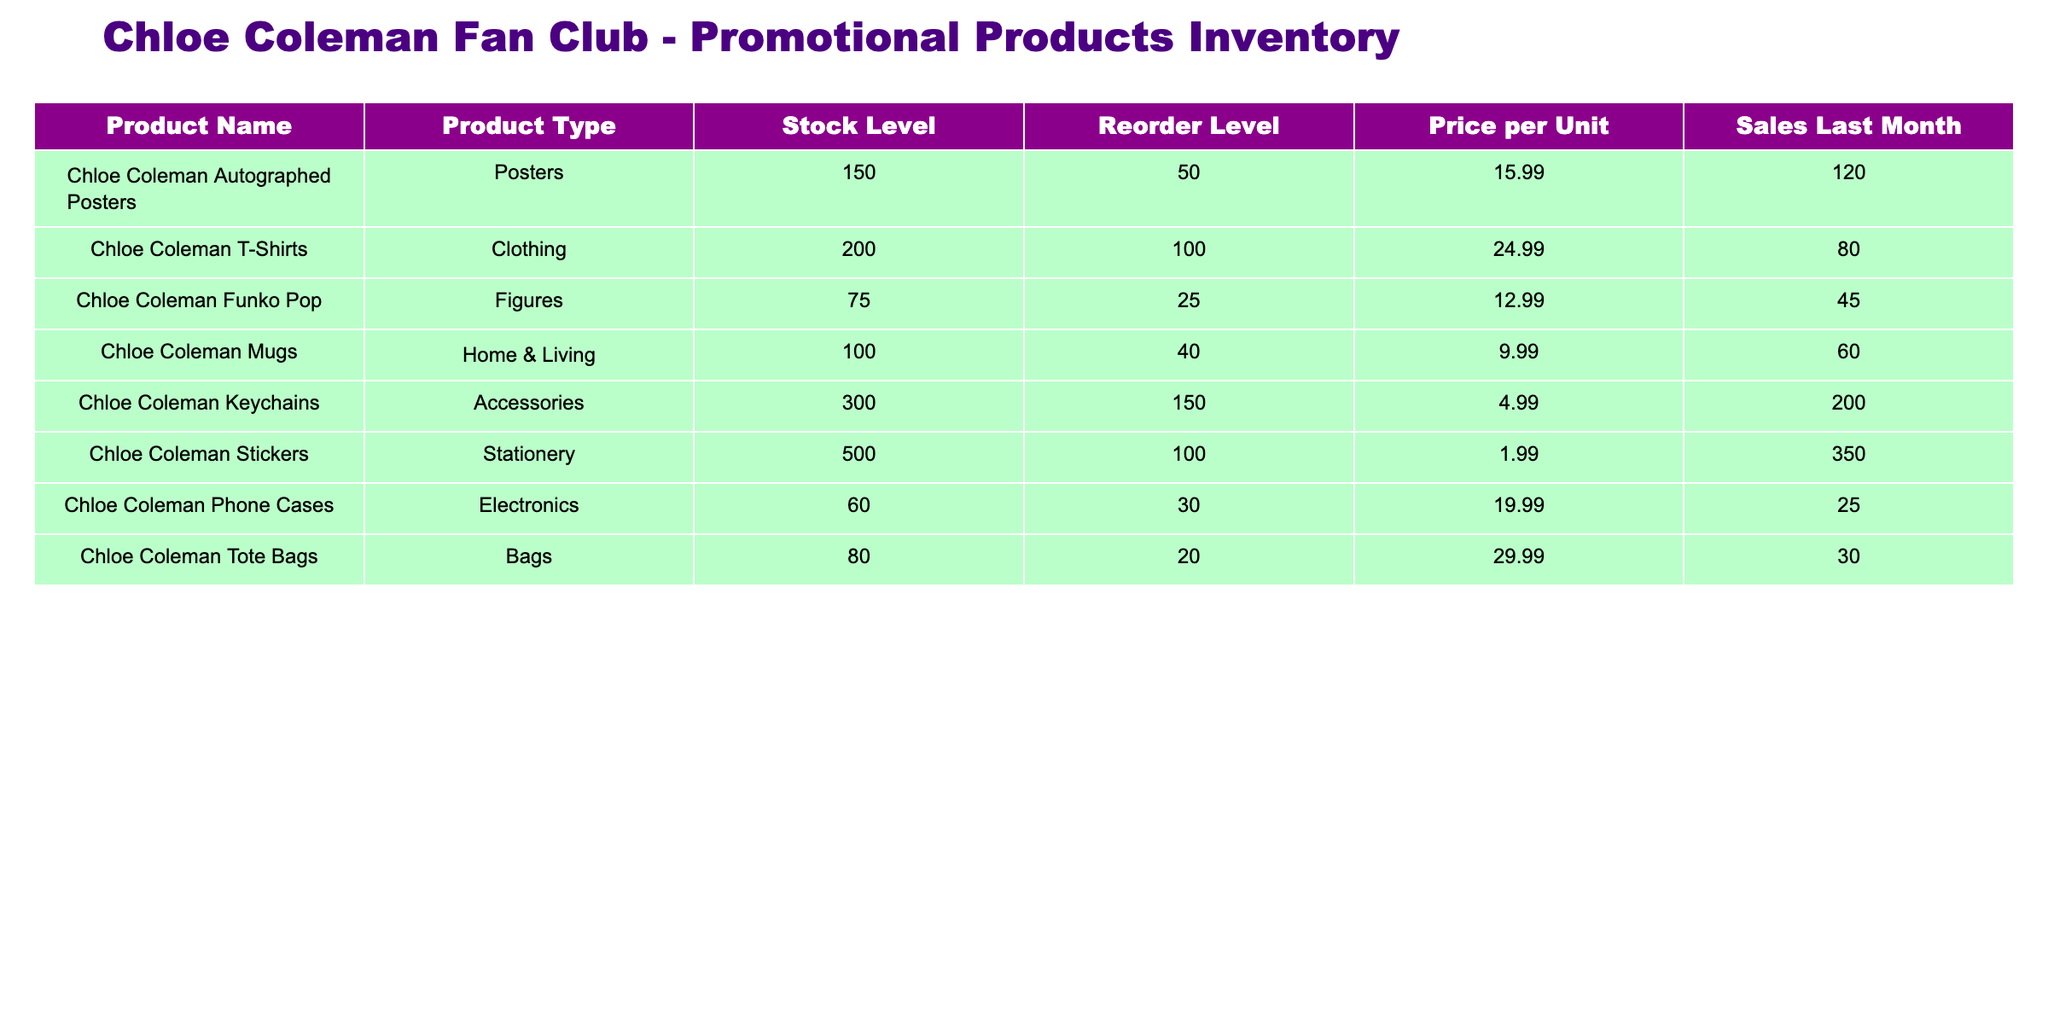What is the stock level of Chloe Coleman Mugs? The stock level of Chloe Coleman Mugs is directly listed in the table under the "Stock Level" column for that product. It shows a value of 100.
Answer: 100 How many products are below their reorder levels? To find the products below their reorder levels, I check the "Stock Level" against the "Reorder Level." I see that the Funko Pop (75), Phone Cases (60), and Tote Bags (80) are below their respective reorder levels of 25, 30, and 20. This counts to 3 products.
Answer: 3 Which product type has the highest stock level? I scan through the "Stock Level" column, identifying the highest number which is 500 for Chloe Coleman Stickers. Therefore, the product type with the highest stock level is Stickers.
Answer: Stickers Do any products have sales last month greater than 100 units? I check the "Sales Last Month" column to see values greater than 100. I find that Keychains (200), Stickers (350), and Posters (120) meet this criterion, confirming that yes, some products have sales above 100.
Answer: Yes What is the average price per unit for the clothing products? I identify the clothing products, which are Chloe Coleman T-Shirts, priced at 24.99, and considering there are no other clothing items, I average the price which is also 24.99, as 24.99/1 = 24.99.
Answer: 24.99 How many more stock levels does Chloe Coleman Keychains have compared to Phone Cases? I compare the stock levels: Keychains have 300 and Phone Cases have 60. To find the difference, I subtract Phone Cases from Keychains: 300 - 60 = 240. Therefore, Keychains have 240 more stock levels than Phone Cases.
Answer: 240 Which product has the highest sales last month and what was that amount? I review the "Sales Last Month" column and identify the highest number, which is 350 for Chloe Coleman Stickers. This makes Stickers the product with the highest sales last month.
Answer: 350 Is there any product type that has a stock level equal to its reorder level? I look through the table to find any stock levels that match their reorder levels. No products in the list display this, confirming that there's no match.
Answer: No What is the total stock level of all products combined? To find the total stock level, I add all the stock levels: 150 (Posters) + 200 (T-Shirts) + 75 (Funko Pop) + 100 (Mugs) + 300 (Keychains) + 500 (Stickers) + 60 (Phone Cases) + 80 (Tote Bags) = 1465.
Answer: 1465 